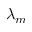<formula> <loc_0><loc_0><loc_500><loc_500>\lambda _ { m }</formula> 